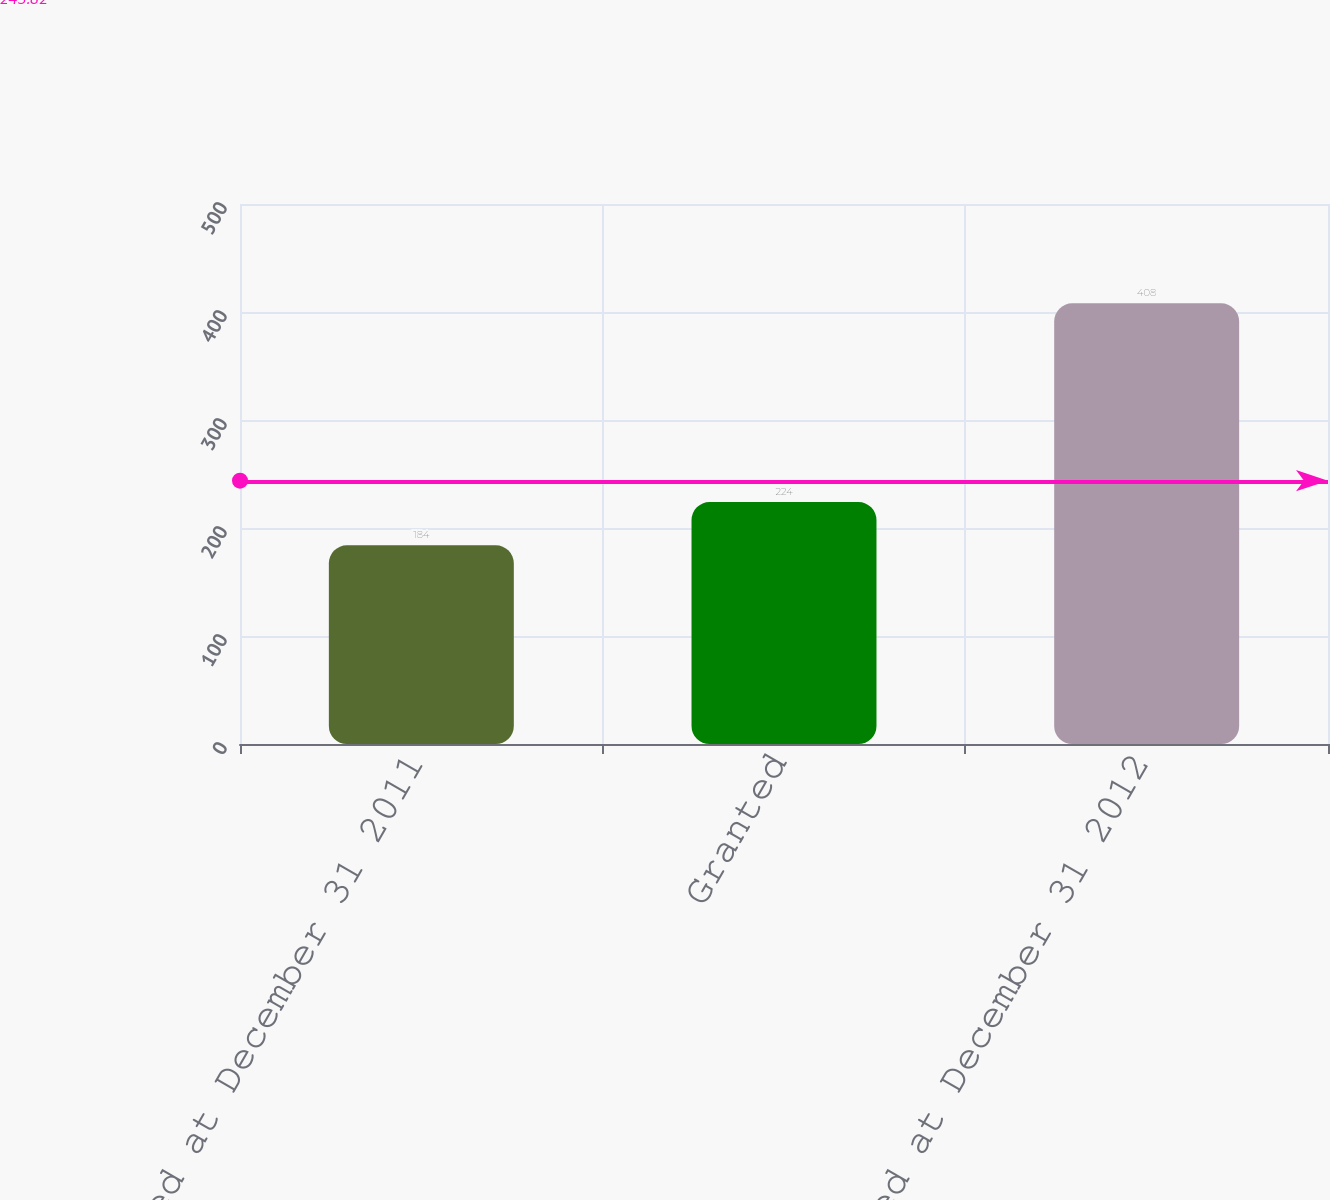Convert chart to OTSL. <chart><loc_0><loc_0><loc_500><loc_500><bar_chart><fcel>Unvested at December 31 2011<fcel>Granted<fcel>Unvested at December 31 2012<nl><fcel>184<fcel>224<fcel>408<nl></chart> 